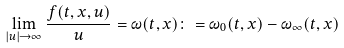Convert formula to latex. <formula><loc_0><loc_0><loc_500><loc_500>\lim _ { | u | \to \infty } \frac { f ( t , x , u ) } { u } = \omega ( t , x ) \colon = \omega _ { 0 } ( t , x ) - \omega _ { \infty } ( t , x )</formula> 